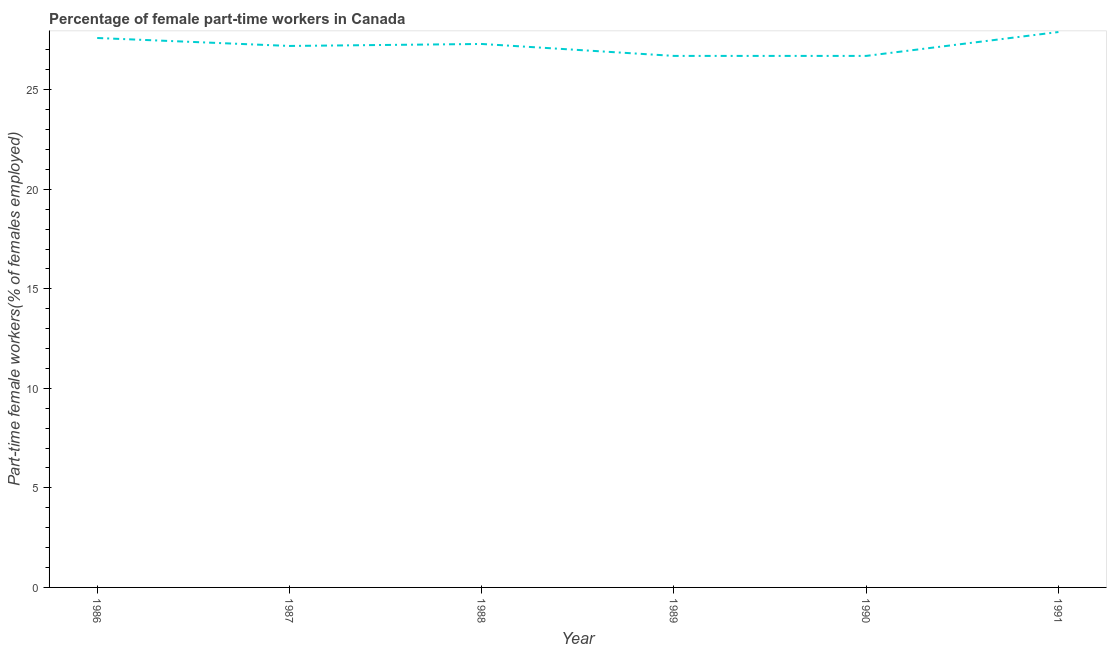What is the percentage of part-time female workers in 1990?
Provide a short and direct response. 26.7. Across all years, what is the maximum percentage of part-time female workers?
Ensure brevity in your answer.  27.9. Across all years, what is the minimum percentage of part-time female workers?
Your answer should be very brief. 26.7. In which year was the percentage of part-time female workers minimum?
Keep it short and to the point. 1989. What is the sum of the percentage of part-time female workers?
Ensure brevity in your answer.  163.4. What is the difference between the percentage of part-time female workers in 1986 and 1991?
Provide a succinct answer. -0.3. What is the average percentage of part-time female workers per year?
Offer a terse response. 27.23. What is the median percentage of part-time female workers?
Provide a succinct answer. 27.25. In how many years, is the percentage of part-time female workers greater than 14 %?
Keep it short and to the point. 6. Do a majority of the years between 1990 and 1988 (inclusive) have percentage of part-time female workers greater than 25 %?
Give a very brief answer. No. What is the ratio of the percentage of part-time female workers in 1986 to that in 1990?
Give a very brief answer. 1.03. Is the difference between the percentage of part-time female workers in 1988 and 1990 greater than the difference between any two years?
Your answer should be compact. No. What is the difference between the highest and the second highest percentage of part-time female workers?
Offer a terse response. 0.3. What is the difference between the highest and the lowest percentage of part-time female workers?
Offer a very short reply. 1.2. How many lines are there?
Your answer should be very brief. 1. What is the difference between two consecutive major ticks on the Y-axis?
Your response must be concise. 5. Does the graph contain any zero values?
Make the answer very short. No. What is the title of the graph?
Offer a terse response. Percentage of female part-time workers in Canada. What is the label or title of the X-axis?
Offer a very short reply. Year. What is the label or title of the Y-axis?
Give a very brief answer. Part-time female workers(% of females employed). What is the Part-time female workers(% of females employed) in 1986?
Make the answer very short. 27.6. What is the Part-time female workers(% of females employed) in 1987?
Your answer should be very brief. 27.2. What is the Part-time female workers(% of females employed) in 1988?
Offer a terse response. 27.3. What is the Part-time female workers(% of females employed) of 1989?
Offer a terse response. 26.7. What is the Part-time female workers(% of females employed) of 1990?
Offer a very short reply. 26.7. What is the Part-time female workers(% of females employed) in 1991?
Ensure brevity in your answer.  27.9. What is the difference between the Part-time female workers(% of females employed) in 1986 and 1987?
Keep it short and to the point. 0.4. What is the difference between the Part-time female workers(% of females employed) in 1986 and 1988?
Give a very brief answer. 0.3. What is the difference between the Part-time female workers(% of females employed) in 1986 and 1989?
Give a very brief answer. 0.9. What is the difference between the Part-time female workers(% of females employed) in 1986 and 1990?
Offer a very short reply. 0.9. What is the difference between the Part-time female workers(% of females employed) in 1987 and 1989?
Provide a short and direct response. 0.5. What is the difference between the Part-time female workers(% of females employed) in 1988 and 1989?
Your response must be concise. 0.6. What is the difference between the Part-time female workers(% of females employed) in 1988 and 1990?
Make the answer very short. 0.6. What is the difference between the Part-time female workers(% of females employed) in 1988 and 1991?
Your answer should be very brief. -0.6. What is the difference between the Part-time female workers(% of females employed) in 1989 and 1990?
Your answer should be very brief. 0. What is the difference between the Part-time female workers(% of females employed) in 1990 and 1991?
Offer a terse response. -1.2. What is the ratio of the Part-time female workers(% of females employed) in 1986 to that in 1988?
Your answer should be compact. 1.01. What is the ratio of the Part-time female workers(% of females employed) in 1986 to that in 1989?
Your answer should be compact. 1.03. What is the ratio of the Part-time female workers(% of females employed) in 1986 to that in 1990?
Your response must be concise. 1.03. What is the ratio of the Part-time female workers(% of females employed) in 1987 to that in 1988?
Provide a short and direct response. 1. What is the ratio of the Part-time female workers(% of females employed) in 1987 to that in 1990?
Provide a succinct answer. 1.02. What is the ratio of the Part-time female workers(% of females employed) in 1988 to that in 1990?
Your answer should be very brief. 1.02. What is the ratio of the Part-time female workers(% of females employed) in 1989 to that in 1990?
Your response must be concise. 1. What is the ratio of the Part-time female workers(% of females employed) in 1989 to that in 1991?
Offer a very short reply. 0.96. 